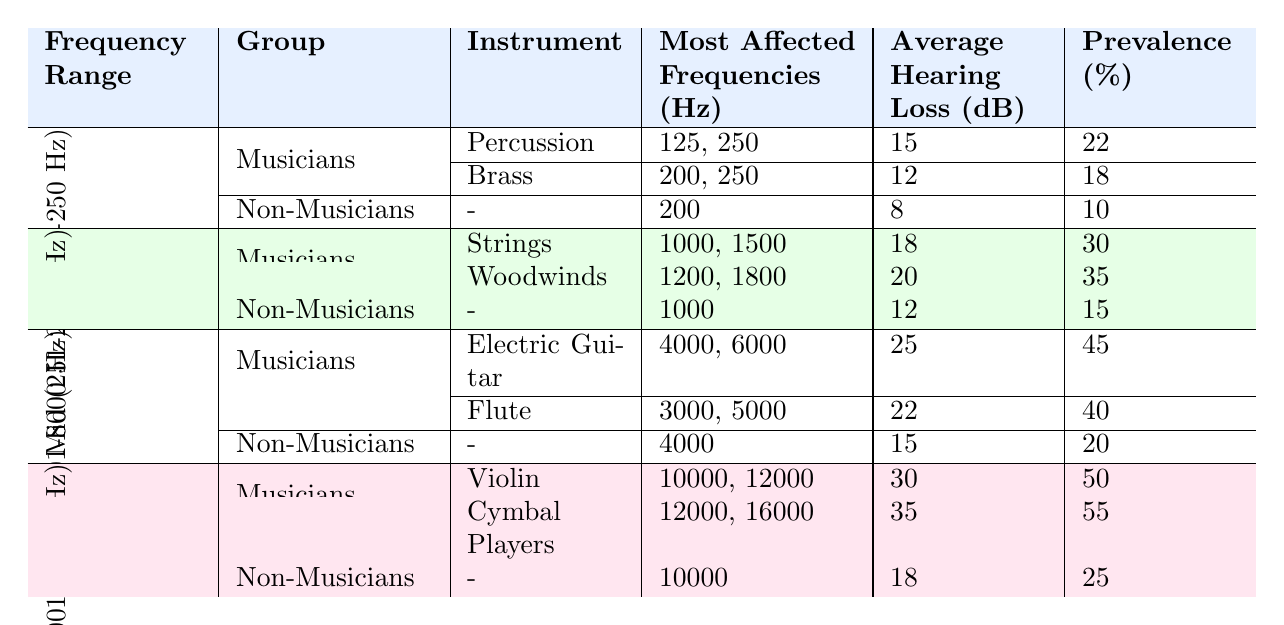What is the average hearing loss for percussion musicians in low frequency ranges? The table indicates that percussion musicians have an average hearing loss of 15 dB in the low frequency range.
Answer: 15 dB Which instrument group has the highest average hearing loss in the mid-frequency range? According to the table, woodwinds have an average hearing loss of 20 dB, while strings have 18 dB. Therefore, woodwinds have the highest average hearing loss.
Answer: Woodwinds What is the prevalence of hearing loss for electric guitar musicians? The table shows that electric guitar musicians have a prevalence of 45% for hearing loss in the high frequency range.
Answer: 45% Is the average hearing loss for non-musicians lower than that of percussion musicians in low frequency ranges? The average hearing loss for non-musicians in the low frequency range is 8 dB, whereas percussion musicians have an average of 15 dB. Therefore, non-musicians have lower hearing loss.
Answer: Yes In which frequency range do cymbal players experience the highest prevalence of hearing loss? The table indicates that cymbal players have a prevalence of 55% in the very high frequency range, which is the highest among all groups listed.
Answer: Very High (8001-20000 Hz) What is the difference in average hearing loss between brass musicians and non-musicians in low frequency ranges? Brass musicians have an average hearing loss of 12 dB while non-musicians have 8 dB. The difference is 12 - 8 = 4 dB.
Answer: 4 dB If we sum the prevalence percentages of all musician groups listed in the mid-frequency range, what is the total? The prevalence percentages for strings (30%) and woodwinds (35%) sum to 30 + 35 = 65%.
Answer: 65% Which frequency range shows the highest average hearing loss among musicians and what is that value? The table shows that the very high frequency range has the highest average hearing loss for musicians, specifically 30 dB for violin and 35 dB for cymbal players, averaging to 32.5 dB.
Answer: 32.5 dB Are the most affected frequencies for non-musicians in the high frequency range the same as for electric guitar musicians? Electric guitar musicians are most affected at 4000 and 6000 Hz, while non-musicians are most affected at 4000 Hz. Since they both include 4000 Hz, the answer is yes.
Answer: Yes What instrument groups have an average hearing loss that exceeds the average for non-musicians in their respective ranges? Percussion and brass musicians both have higher average losses (15 dB and 12 dB respectively) compared to non-musicians (8 dB) in the low range; woodwinds and strings have higher losses (20 dB and 18 dB) compared to non-musicians (12 dB) in the mid range; electric guitar and flute also exceed non-musicians (15 dB) in the high range (25 dB and 22 dB). Therefore, all musician groups exceed the non-musician's losses in their ranges.
Answer: Yes, all musician groups exceed non-musicians 